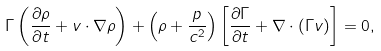Convert formula to latex. <formula><loc_0><loc_0><loc_500><loc_500>\Gamma \left ( \frac { \partial \rho } { \partial t } + { v } \cdot \nabla \rho \right ) + \left ( \rho + \frac { p } { c ^ { 2 } } \right ) \left [ \frac { \partial \Gamma } { \partial t } + \nabla \cdot ( \Gamma { v } ) \right ] = 0 ,</formula> 